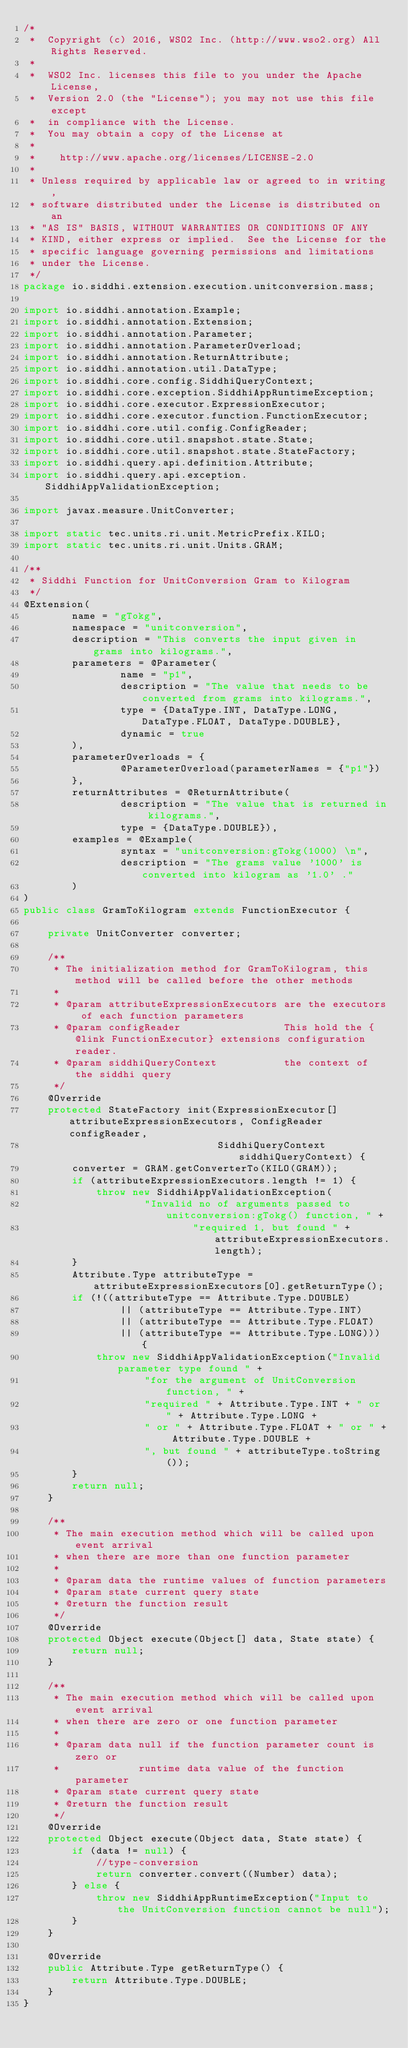Convert code to text. <code><loc_0><loc_0><loc_500><loc_500><_Java_>/*
 *  Copyright (c) 2016, WSO2 Inc. (http://www.wso2.org) All Rights Reserved.
 *
 *  WSO2 Inc. licenses this file to you under the Apache License,
 *  Version 2.0 (the "License"); you may not use this file except
 *  in compliance with the License.
 *  You may obtain a copy of the License at
 *
 *    http://www.apache.org/licenses/LICENSE-2.0
 *
 * Unless required by applicable law or agreed to in writing,
 * software distributed under the License is distributed on an
 * "AS IS" BASIS, WITHOUT WARRANTIES OR CONDITIONS OF ANY
 * KIND, either express or implied.  See the License for the
 * specific language governing permissions and limitations
 * under the License.
 */
package io.siddhi.extension.execution.unitconversion.mass;

import io.siddhi.annotation.Example;
import io.siddhi.annotation.Extension;
import io.siddhi.annotation.Parameter;
import io.siddhi.annotation.ParameterOverload;
import io.siddhi.annotation.ReturnAttribute;
import io.siddhi.annotation.util.DataType;
import io.siddhi.core.config.SiddhiQueryContext;
import io.siddhi.core.exception.SiddhiAppRuntimeException;
import io.siddhi.core.executor.ExpressionExecutor;
import io.siddhi.core.executor.function.FunctionExecutor;
import io.siddhi.core.util.config.ConfigReader;
import io.siddhi.core.util.snapshot.state.State;
import io.siddhi.core.util.snapshot.state.StateFactory;
import io.siddhi.query.api.definition.Attribute;
import io.siddhi.query.api.exception.SiddhiAppValidationException;

import javax.measure.UnitConverter;

import static tec.units.ri.unit.MetricPrefix.KILO;
import static tec.units.ri.unit.Units.GRAM;

/**
 * Siddhi Function for UnitConversion Gram to Kilogram
 */
@Extension(
        name = "gTokg",
        namespace = "unitconversion",
        description = "This converts the input given in grams into kilograms.",
        parameters = @Parameter(
                name = "p1",
                description = "The value that needs to be converted from grams into kilograms.",
                type = {DataType.INT, DataType.LONG, DataType.FLOAT, DataType.DOUBLE},
                dynamic = true
        ),
        parameterOverloads = {
                @ParameterOverload(parameterNames = {"p1"})
        },
        returnAttributes = @ReturnAttribute(
                description = "The value that is returned in kilograms.",
                type = {DataType.DOUBLE}),
        examples = @Example(
                syntax = "unitconversion:gTokg(1000) \n",
                description = "The grams value '1000' is converted into kilogram as '1.0' ."
        )
)
public class GramToKilogram extends FunctionExecutor {

    private UnitConverter converter;

    /**
     * The initialization method for GramToKilogram, this method will be called before the other methods
     *
     * @param attributeExpressionExecutors are the executors of each function parameters
     * @param configReader                 This hold the {@link FunctionExecutor} extensions configuration reader.
     * @param siddhiQueryContext           the context of the siddhi query
     */
    @Override
    protected StateFactory init(ExpressionExecutor[] attributeExpressionExecutors, ConfigReader configReader,
                                SiddhiQueryContext siddhiQueryContext) {
        converter = GRAM.getConverterTo(KILO(GRAM));
        if (attributeExpressionExecutors.length != 1) {
            throw new SiddhiAppValidationException(
                    "Invalid no of arguments passed to unitconversion:gTokg() function, " +
                            "required 1, but found " + attributeExpressionExecutors.length);
        }
        Attribute.Type attributeType = attributeExpressionExecutors[0].getReturnType();
        if (!((attributeType == Attribute.Type.DOUBLE)
                || (attributeType == Attribute.Type.INT)
                || (attributeType == Attribute.Type.FLOAT)
                || (attributeType == Attribute.Type.LONG))) {
            throw new SiddhiAppValidationException("Invalid parameter type found " +
                    "for the argument of UnitConversion function, " +
                    "required " + Attribute.Type.INT + " or " + Attribute.Type.LONG +
                    " or " + Attribute.Type.FLOAT + " or " + Attribute.Type.DOUBLE +
                    ", but found " + attributeType.toString());
        }
        return null;
    }

    /**
     * The main execution method which will be called upon event arrival
     * when there are more than one function parameter
     *
     * @param data the runtime values of function parameters
     * @param state current query state
     * @return the function result
     */
    @Override
    protected Object execute(Object[] data, State state) {
        return null;
    }

    /**
     * The main execution method which will be called upon event arrival
     * when there are zero or one function parameter
     *
     * @param data null if the function parameter count is zero or
     *             runtime data value of the function parameter
     * @param state current query state
     * @return the function result
     */
    @Override
    protected Object execute(Object data, State state) {
        if (data != null) {
            //type-conversion
            return converter.convert((Number) data);
        } else {
            throw new SiddhiAppRuntimeException("Input to the UnitConversion function cannot be null");
        }
    }

    @Override
    public Attribute.Type getReturnType() {
        return Attribute.Type.DOUBLE;
    }
}
</code> 